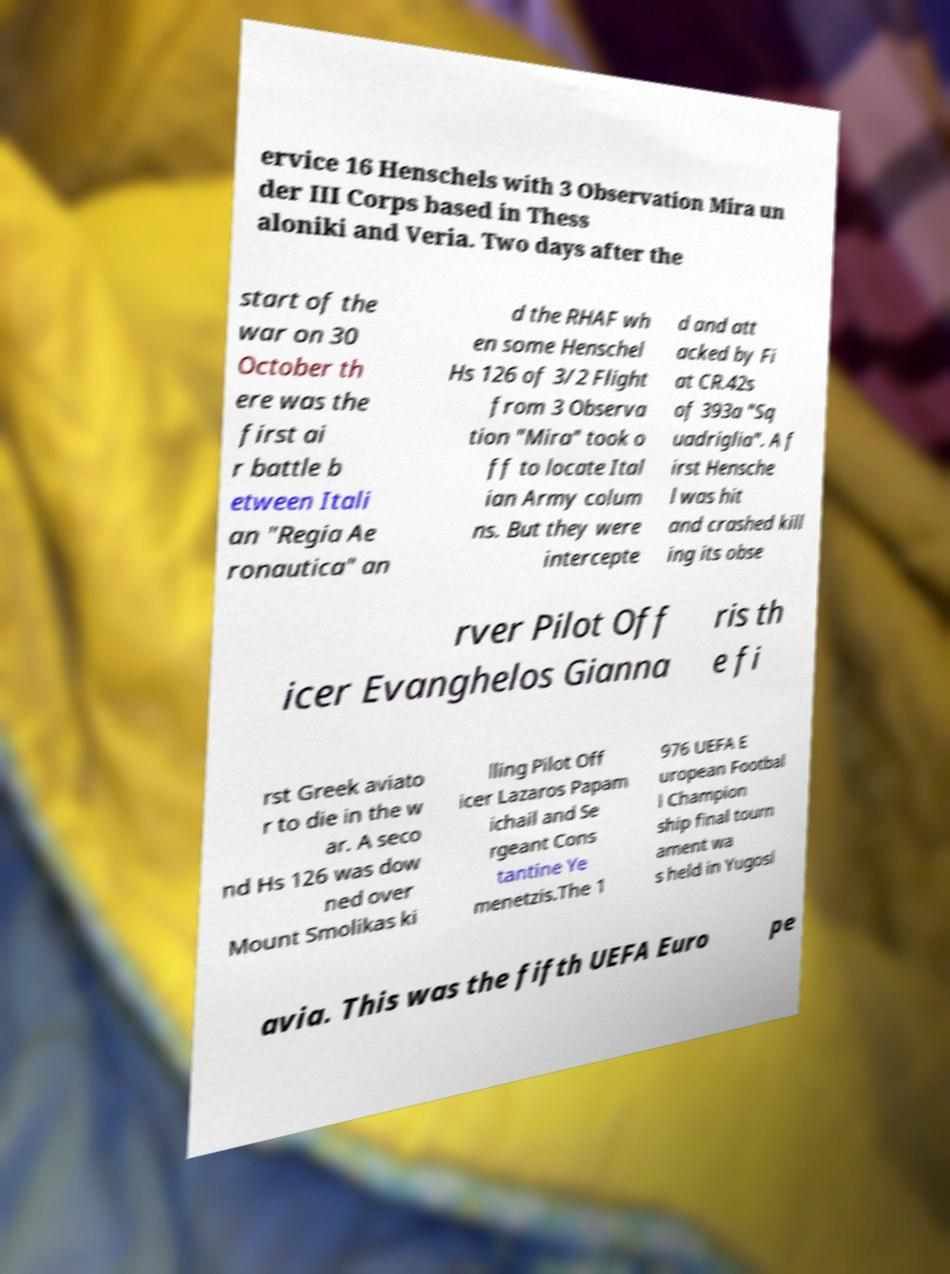Can you accurately transcribe the text from the provided image for me? ervice 16 Henschels with 3 Observation Mira un der III Corps based in Thess aloniki and Veria. Two days after the start of the war on 30 October th ere was the first ai r battle b etween Itali an "Regia Ae ronautica" an d the RHAF wh en some Henschel Hs 126 of 3/2 Flight from 3 Observa tion "Mira" took o ff to locate Ital ian Army colum ns. But they were intercepte d and att acked by Fi at CR.42s of 393a "Sq uadriglia". A f irst Hensche l was hit and crashed kill ing its obse rver Pilot Off icer Evanghelos Gianna ris th e fi rst Greek aviato r to die in the w ar. A seco nd Hs 126 was dow ned over Mount Smolikas ki lling Pilot Off icer Lazaros Papam ichail and Se rgeant Cons tantine Ye menetzis.The 1 976 UEFA E uropean Footbal l Champion ship final tourn ament wa s held in Yugosl avia. This was the fifth UEFA Euro pe 